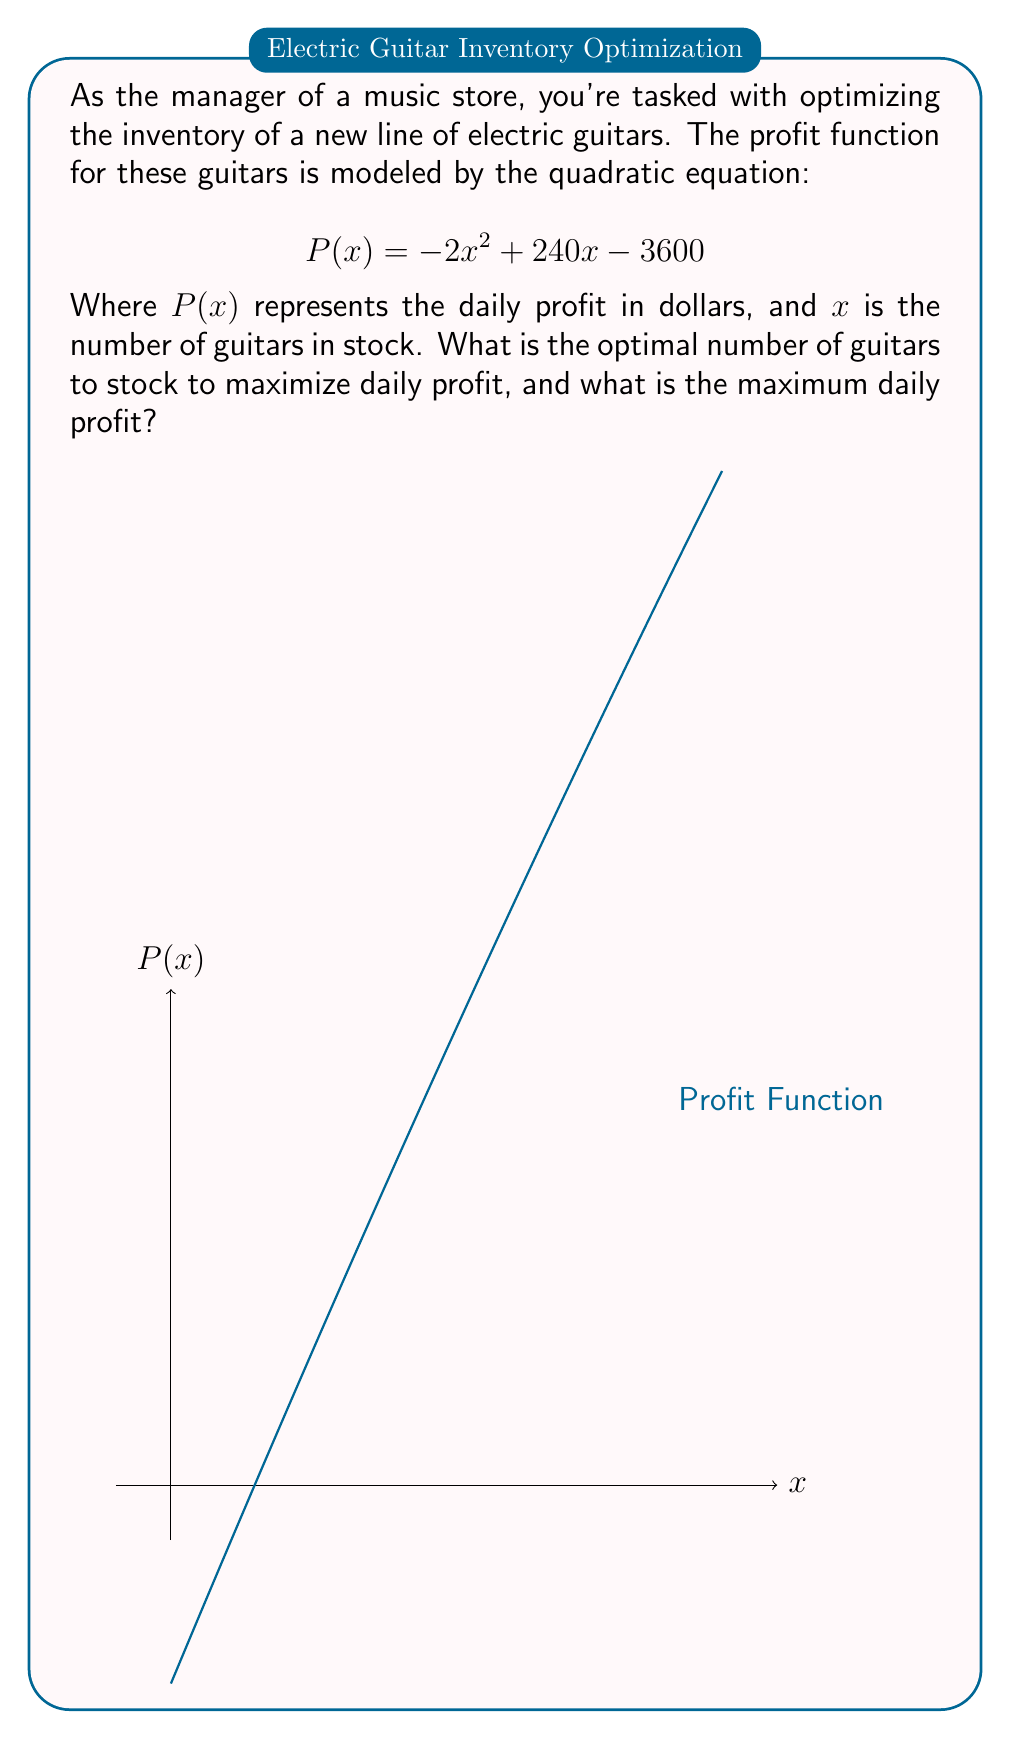Can you solve this math problem? To solve this problem, we'll follow these steps:

1) The profit function is a quadratic equation in the form $P(x) = ax^2 + bx + c$, where:
   $a = -2$, $b = 240$, and $c = -3600$

2) For a quadratic function, the maximum or minimum occurs at the vertex. Since $a$ is negative, this parabola opens downward, so the vertex will be the maximum point.

3) To find the x-coordinate of the vertex, we use the formula: $x = -\frac{b}{2a}$

   $$x = -\frac{240}{2(-2)} = -\frac{240}{-4} = 60$$

4) This means the optimal number of guitars to stock is 60.

5) To find the maximum profit, we substitute $x = 60$ into the original equation:

   $$P(60) = -2(60)^2 + 240(60) - 3600$$
   $$= -2(3600) + 14400 - 3600$$
   $$= -7200 + 14400 - 3600$$
   $$= 3600$$

6) Therefore, the maximum daily profit is $3600.
Answer: 60 guitars; $3600 